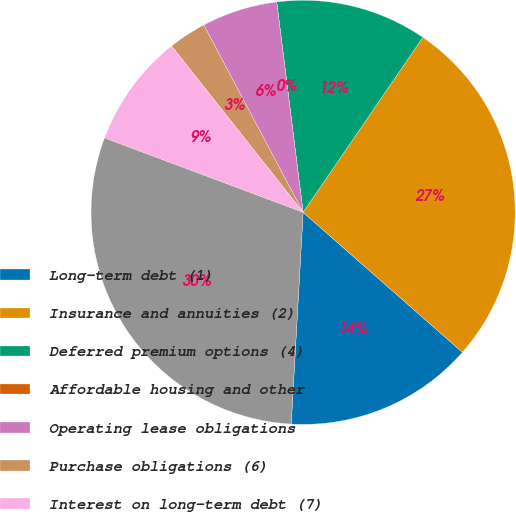Convert chart. <chart><loc_0><loc_0><loc_500><loc_500><pie_chart><fcel>Long-term debt (1)<fcel>Insurance and annuities (2)<fcel>Deferred premium options (4)<fcel>Affordable housing and other<fcel>Operating lease obligations<fcel>Purchase obligations (6)<fcel>Interest on long-term debt (7)<fcel>Total<nl><fcel>14.42%<fcel>26.92%<fcel>11.54%<fcel>0.0%<fcel>5.77%<fcel>2.89%<fcel>8.65%<fcel>29.81%<nl></chart> 